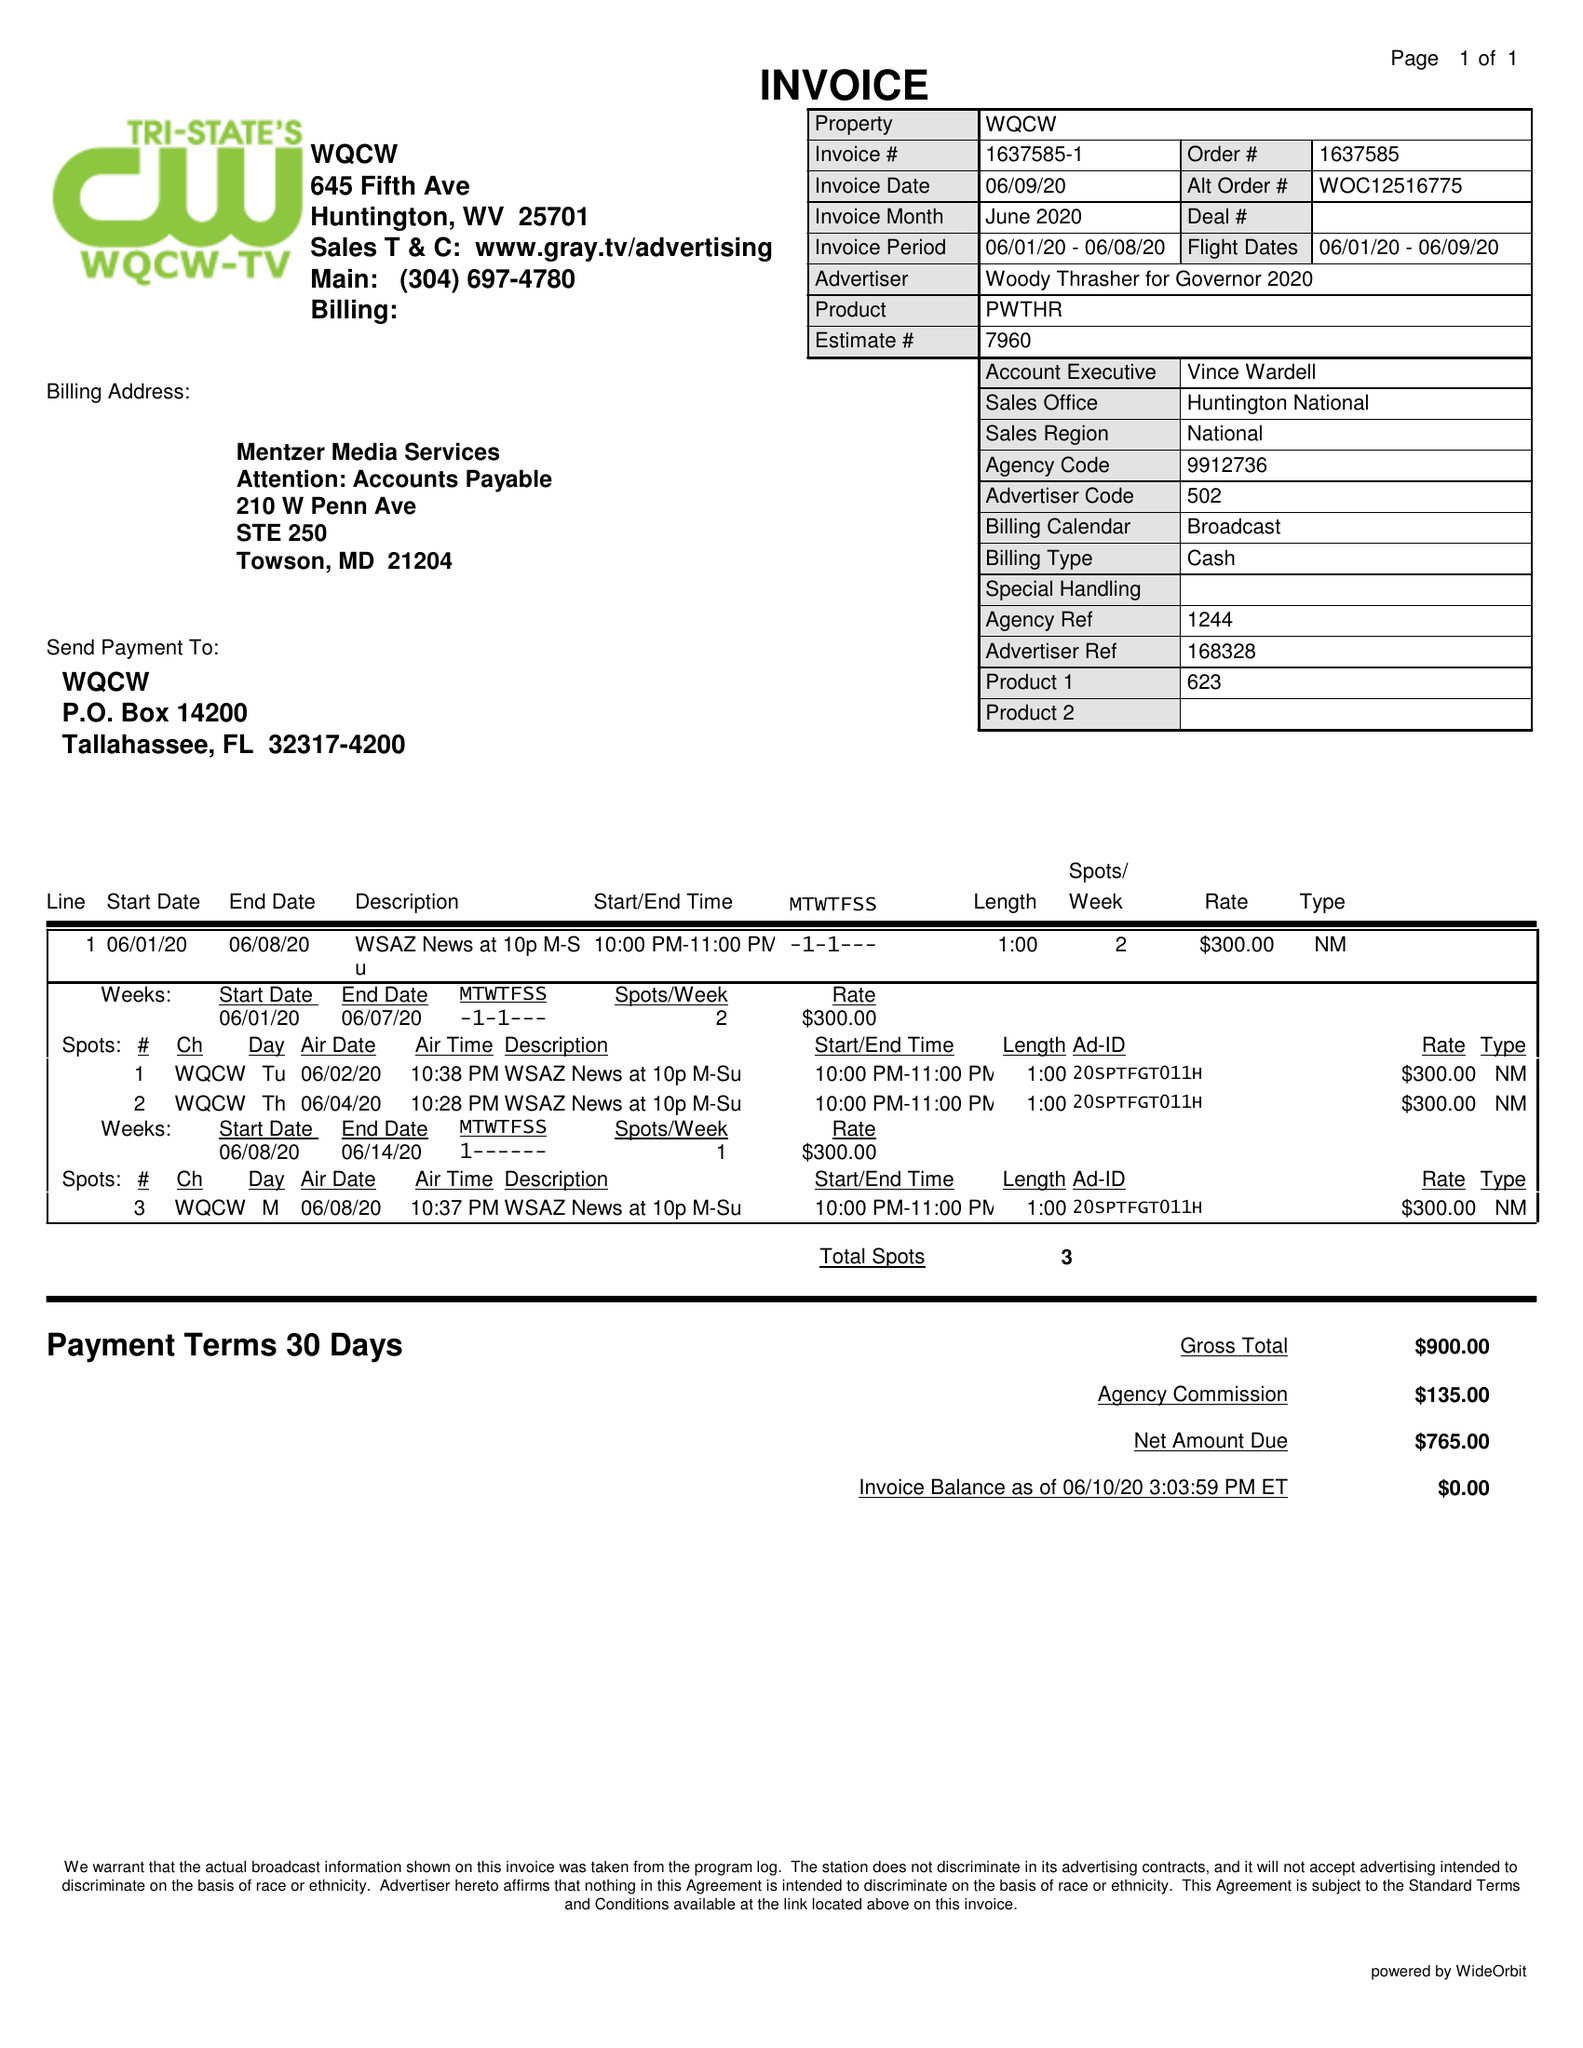What is the value for the flight_from?
Answer the question using a single word or phrase. 06/01/20 